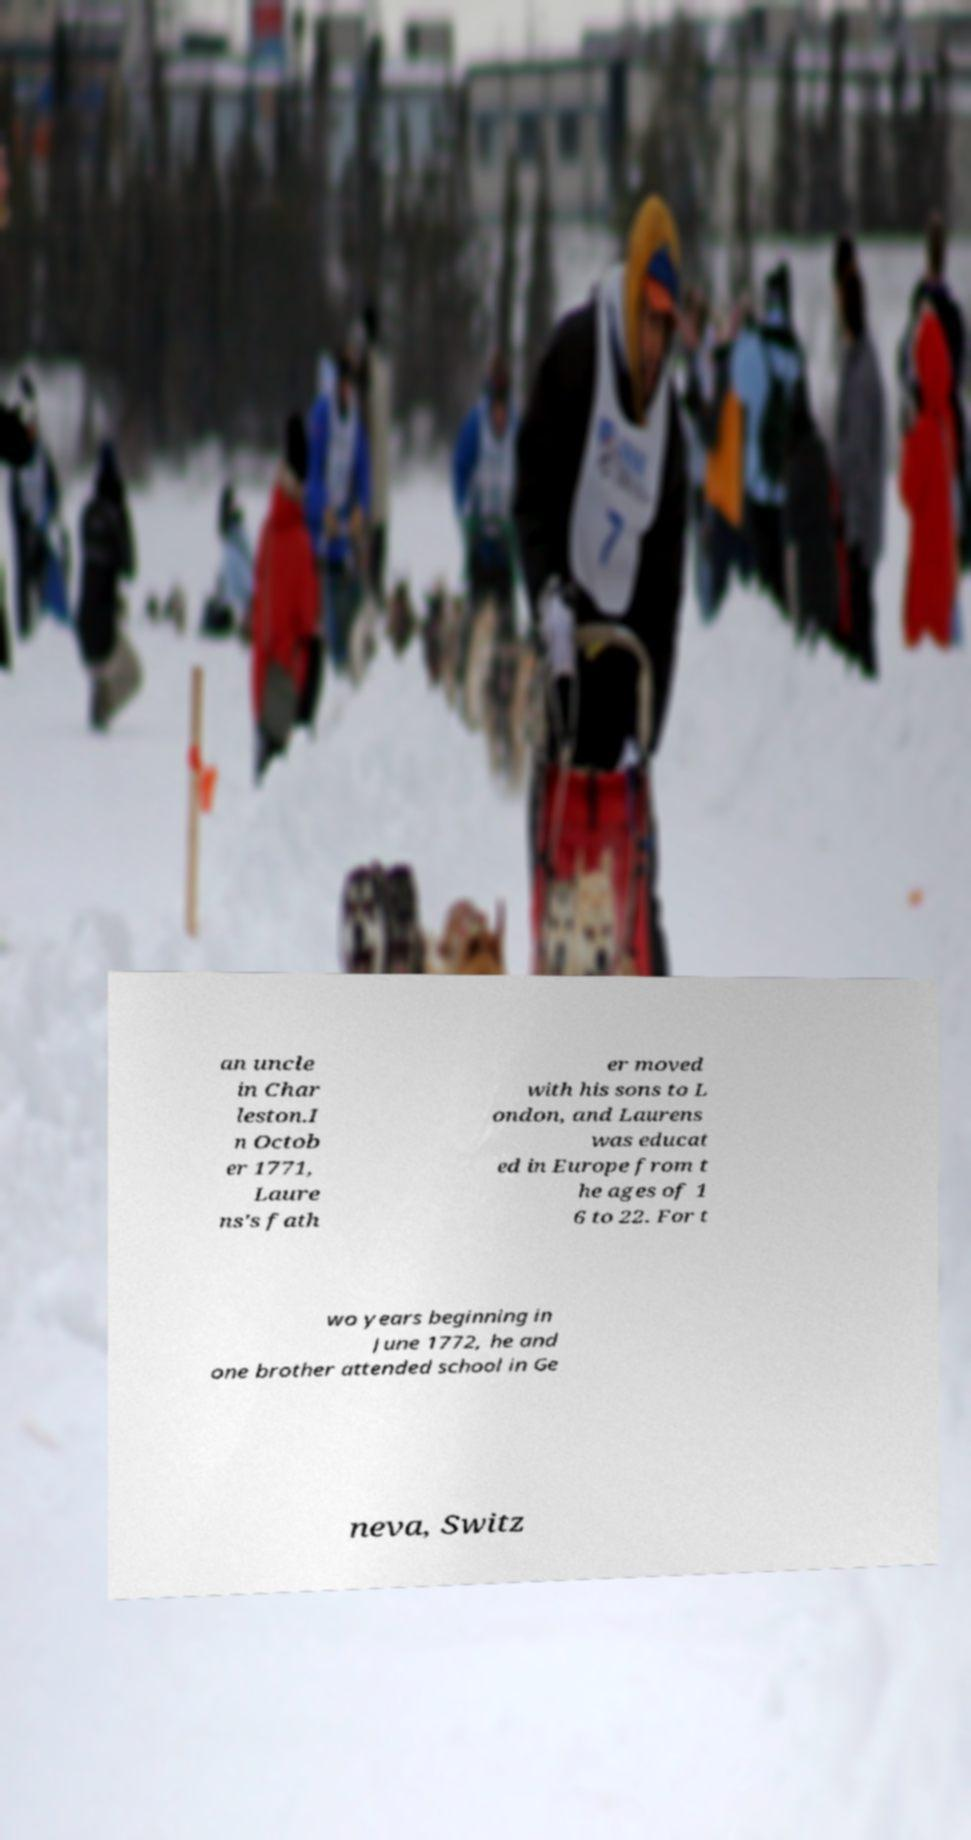Please read and relay the text visible in this image. What does it say? an uncle in Char leston.I n Octob er 1771, Laure ns's fath er moved with his sons to L ondon, and Laurens was educat ed in Europe from t he ages of 1 6 to 22. For t wo years beginning in June 1772, he and one brother attended school in Ge neva, Switz 